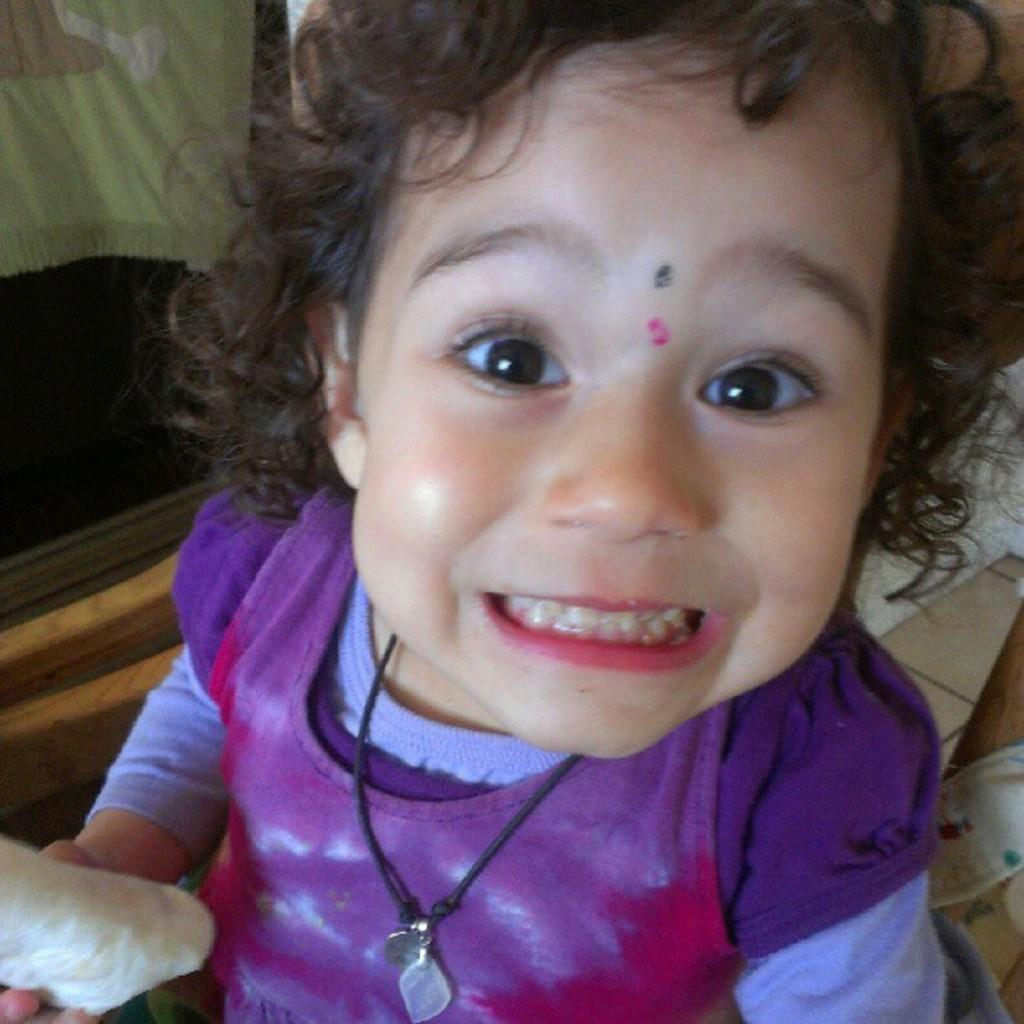Who is the main subject in the image? There is a baby girl in the image. What is the baby girl doing in the image? The baby girl is smiling. Can you describe the baby girl's hair? The baby girl has curly hair. What is the baby girl holding in the image? The baby girl is holding bread. What can be seen on the left side of the image? There is a window on the left side of the image. What type of wax can be seen melting on the trail in the image? There is no trail or wax present in the image; it features a baby girl holding bread. 